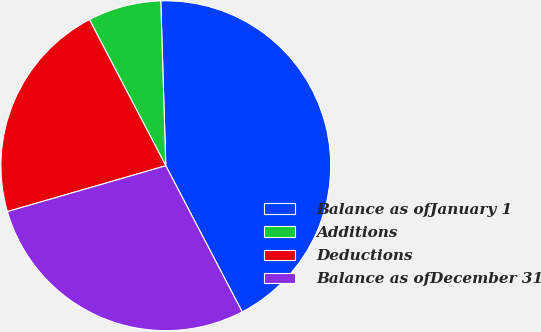Convert chart to OTSL. <chart><loc_0><loc_0><loc_500><loc_500><pie_chart><fcel>Balance as ofJanuary 1<fcel>Additions<fcel>Deductions<fcel>Balance as ofDecember 31<nl><fcel>42.82%<fcel>7.18%<fcel>21.82%<fcel>28.18%<nl></chart> 